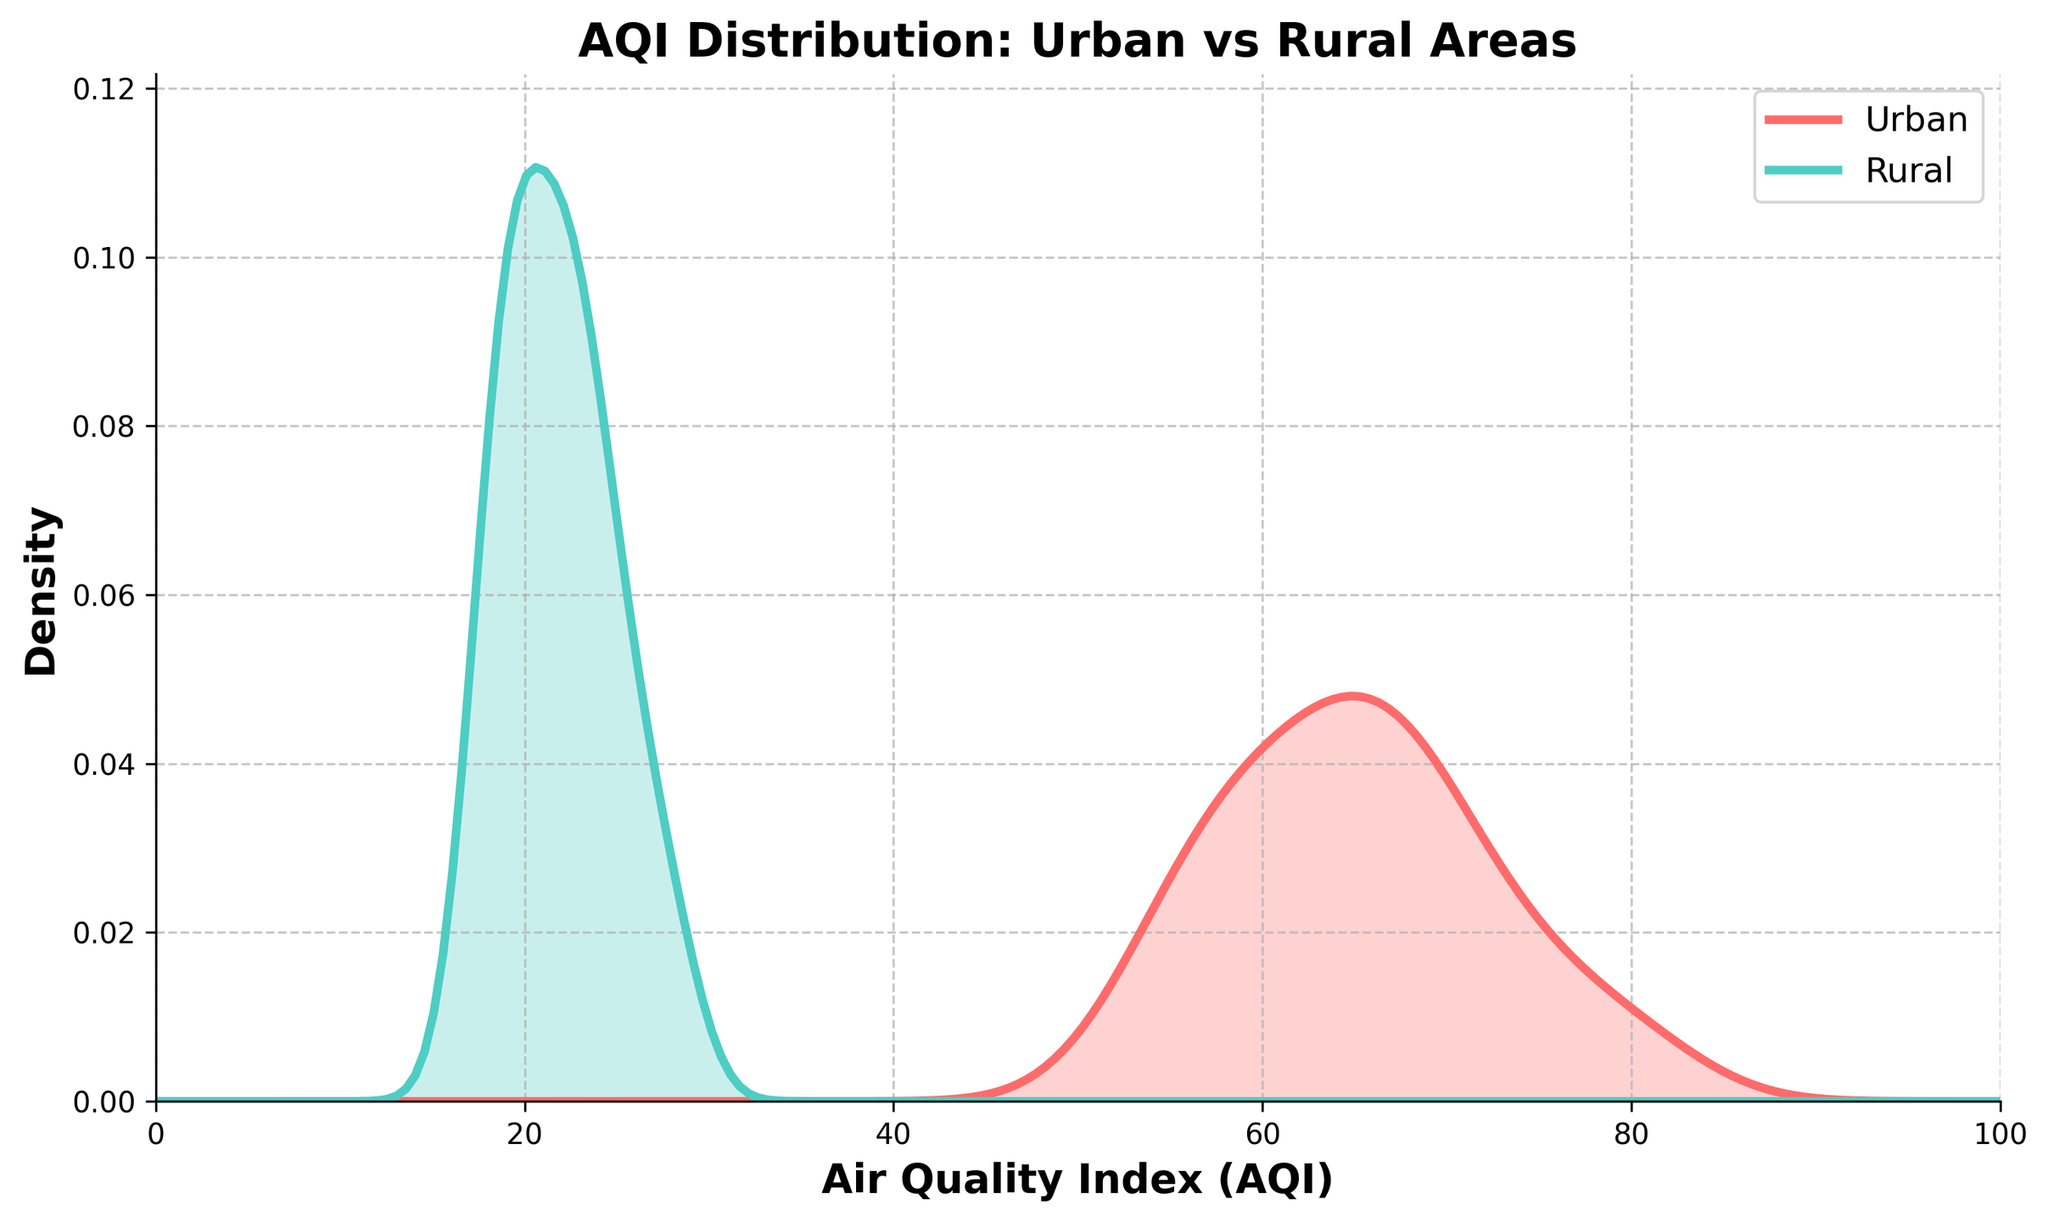What does the title of the figure say? The title of the figure is indicated at the top and provides an overview of the content. It helps viewers understand the subject being analyzed.
Answer: AQI Distribution: Urban vs Rural Areas What does the x-axis represent? The x-axis label indicates what values are being measured horizontally across the plot. In this figure, "Air Quality Index (AQI)" is written, showing that this axis represents the AQI values.
Answer: Air Quality Index (AQI) Which color represents the urban AQI distribution? The color used for the urban distribution is highlighted in the legend on the figure. According to the legend, "Urban" is represented by a reddish color.
Answer: Red Which area has higher AQI values on average, urban or rural? By observing the density curves, the curve with higher AQI values shifted to the right represents the area with higher AQI values. The urban AQI density curve is predominantly to the right of the rural density curve.
Answer: Urban What range does the AQI for rural areas predominantly fall into? Observing the rural density curve peak and its spread along the x-axis indicates the primary AQI range for rural areas. The peak density for rural areas is between 15 and 30 AQI.
Answer: 15-30 Is there a greater spread in AQI values for urban or rural areas? By looking at the width of the density curves along the x-axis, a wider spread indicates a greater range of AQI values. The urban density curve spreads out more compared to the rural density curve.
Answer: Urban Which area has a peak density at a higher AQI value? The peak value on the density curve indicates where the highest density of data points falls. The urban peak density is at higher AQI values than the rural peak density.
Answer: Urban How do the peak densities compare between urban and rural areas? Comparing the height of the peaks of the density curves shows the highest density point for each area. The rural peak is higher compared to the urban peak, indicating a more concentrated distribution at a certain AQI range for rural areas.
Answer: Rural What is the approximate highest density value for urban areas? The peak of the urban density plot represents the highest density value. Observing the y-axis at this peak, it appears around 0.06.
Answer: Around 0.06 Which area appears to have more variability in AQI based on the density plot? Greater variability in AQI is indicated by a wider and more spread-out density curve. The urban density plot is more spread out compared to the rural density plot, indicating more variability in AQI values in urban areas.
Answer: Urban 